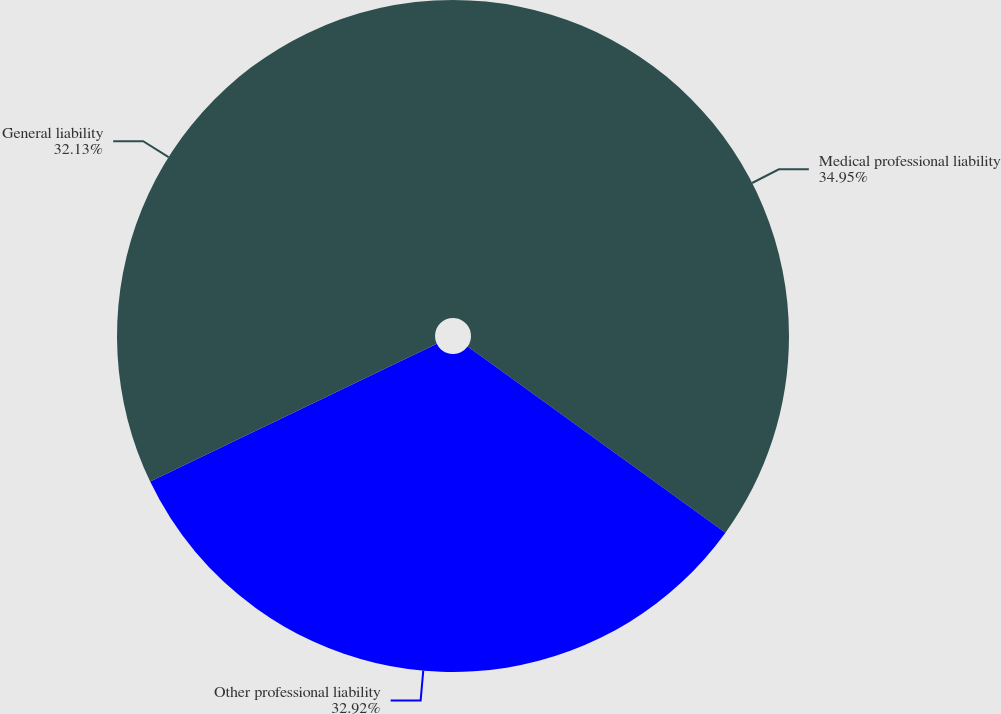Convert chart to OTSL. <chart><loc_0><loc_0><loc_500><loc_500><pie_chart><fcel>Medical professional liability<fcel>Other professional liability<fcel>General liability<nl><fcel>34.95%<fcel>32.92%<fcel>32.13%<nl></chart> 